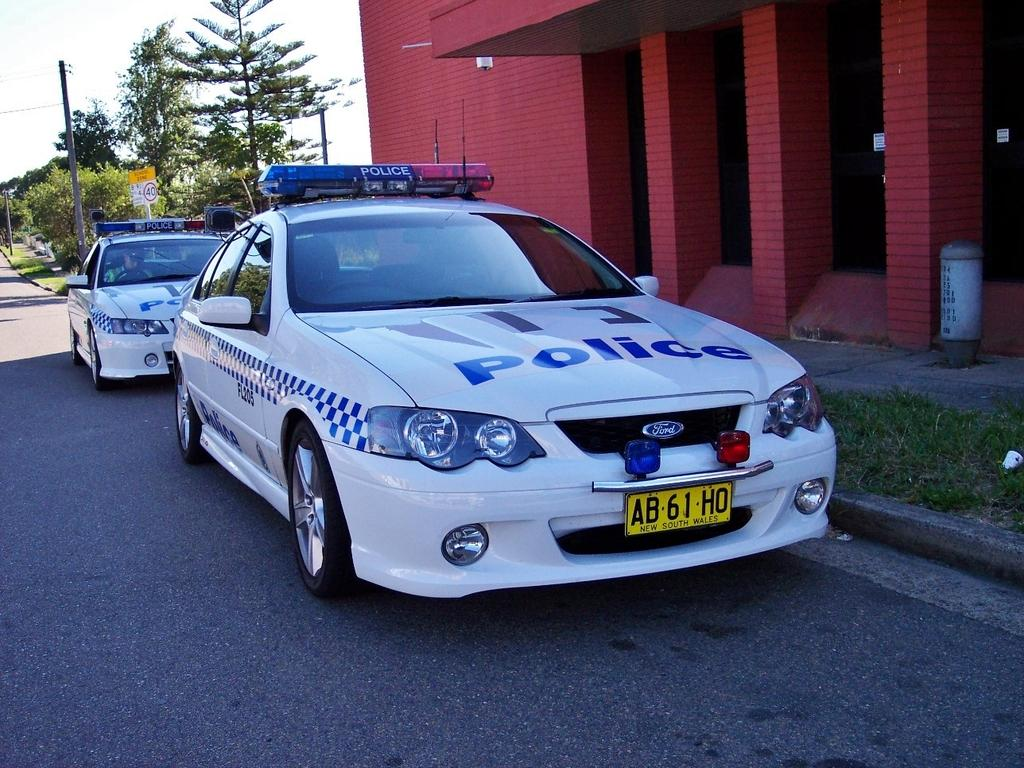What can be seen on the right side of the picture? On the right side of the picture, there are current poles, trees, a board with a pole, pillars, a wall, and grass. What type of vehicles are present on the road? There are police cars on the road. Can you see a carriage being pulled by horses in the image? No, there is no carriage or horses present in the image. How many babies are visible in the image? There are no babies visible in the image. Is there a guitar being played in the image? No, there is no guitar or anyone playing it in the image. 